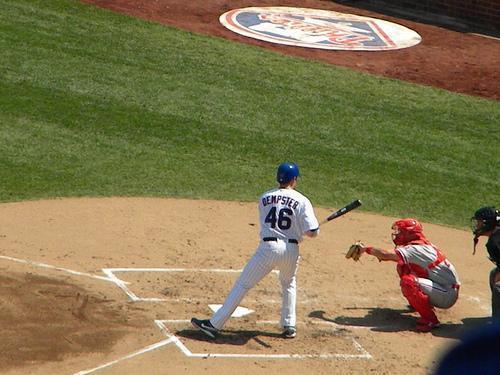What is number 46 waiting for?
From the following four choices, select the correct answer to address the question.
Options: Some rest, ball pitched, lunch, time off. Ball pitched. 